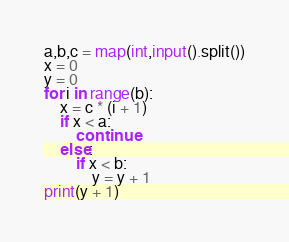<code> <loc_0><loc_0><loc_500><loc_500><_Python_>a,b,c = map(int,input().split())
x = 0
y = 0
for i in range(b):
    x = c * (i + 1)
    if x < a:
        continue
    else:
        if x < b:
            y = y + 1
print(y + 1)</code> 